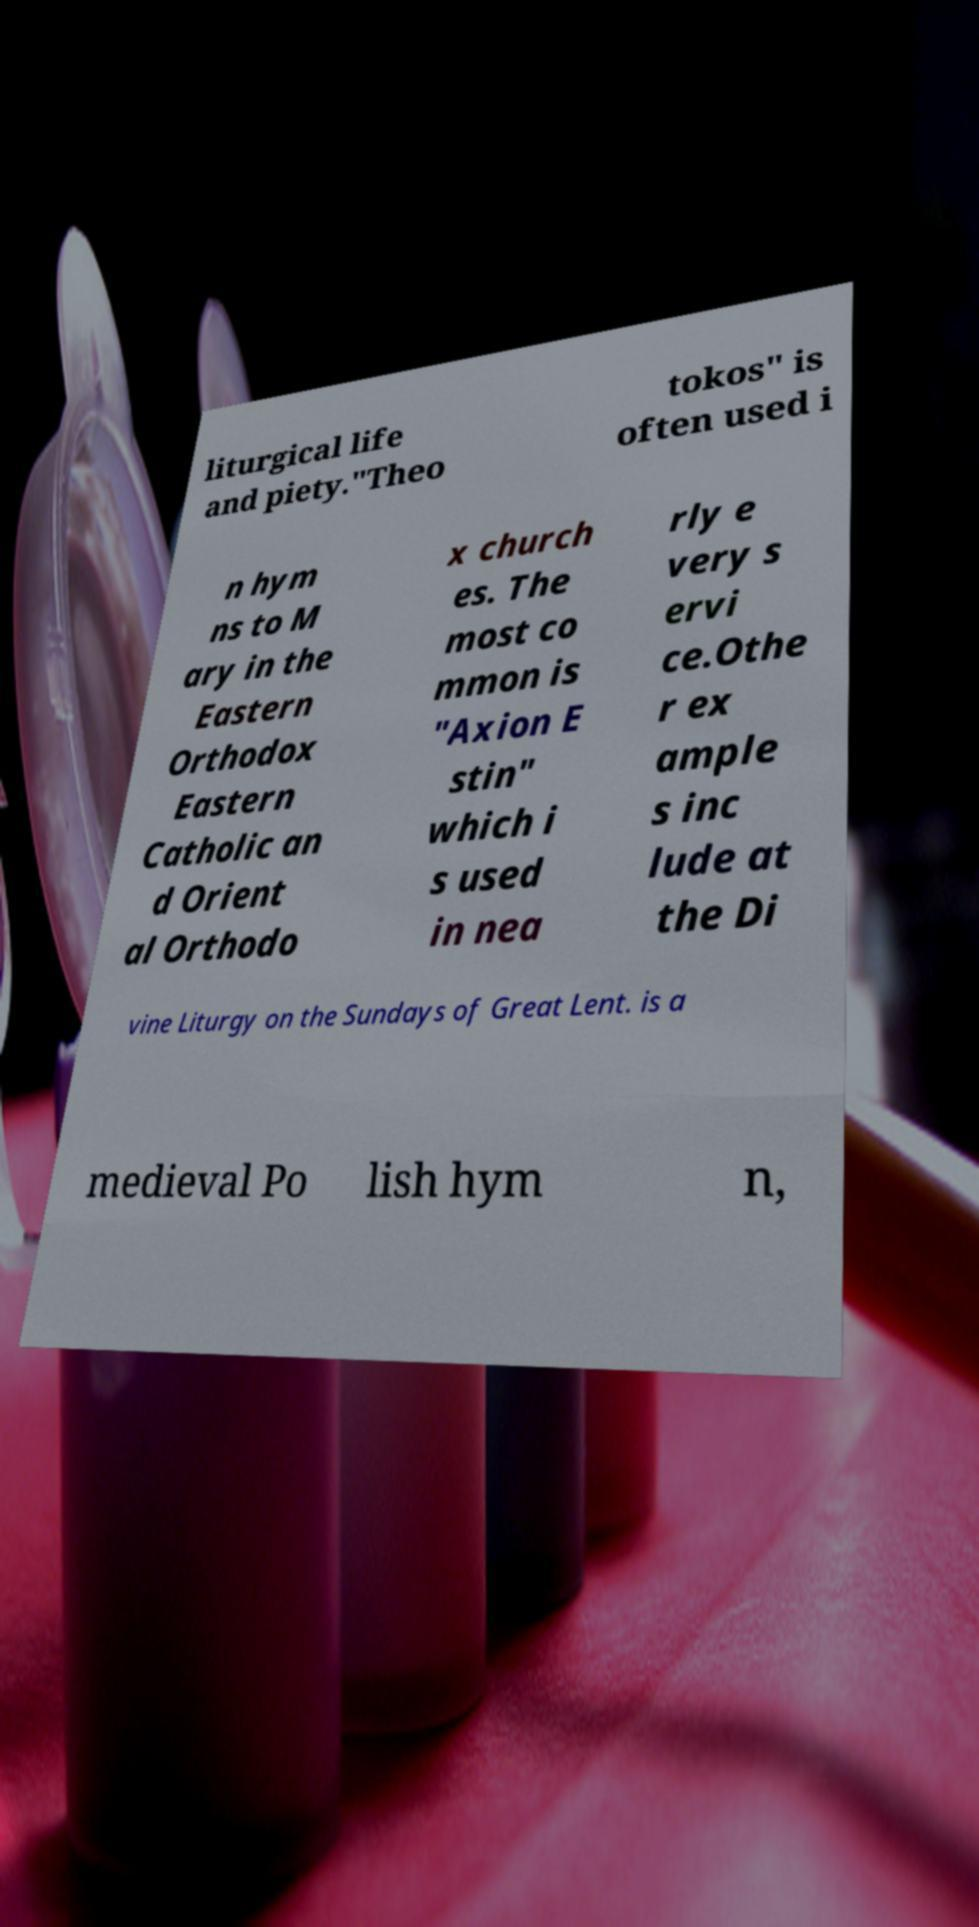Can you accurately transcribe the text from the provided image for me? liturgical life and piety."Theo tokos" is often used i n hym ns to M ary in the Eastern Orthodox Eastern Catholic an d Orient al Orthodo x church es. The most co mmon is "Axion E stin" which i s used in nea rly e very s ervi ce.Othe r ex ample s inc lude at the Di vine Liturgy on the Sundays of Great Lent. is a medieval Po lish hym n, 